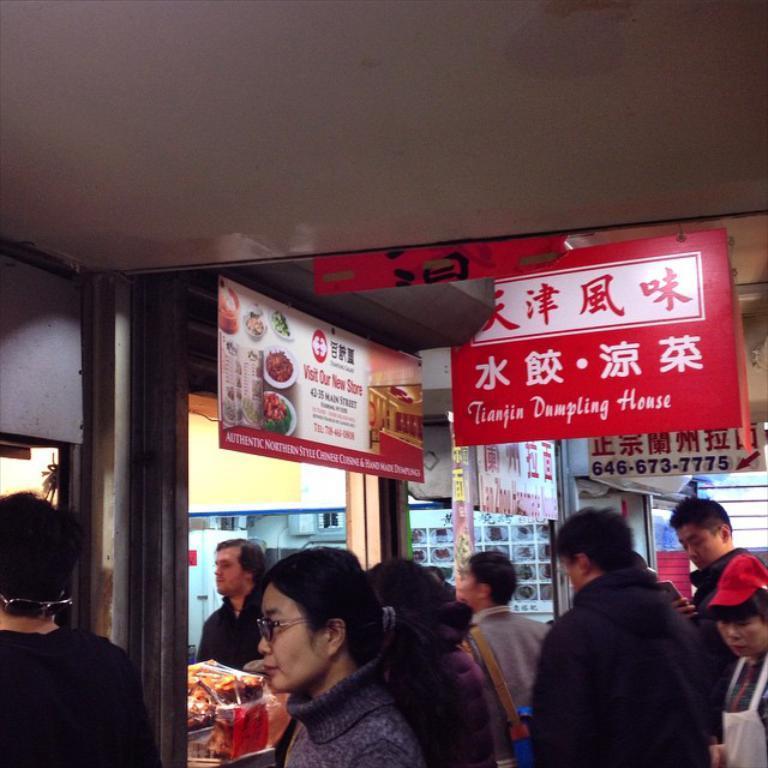Can you describe this image briefly? In the picture I can see people are standing. In the background then I can see boards on which I can see something written on them. I can also see shops, ceiling and some other objects. 